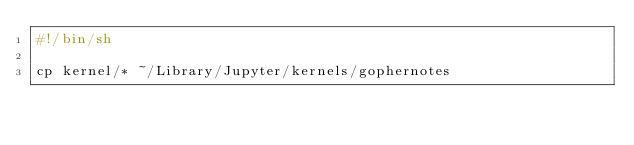<code> <loc_0><loc_0><loc_500><loc_500><_Bash_>#!/bin/sh

cp kernel/* ~/Library/Jupyter/kernels/gophernotes
</code> 